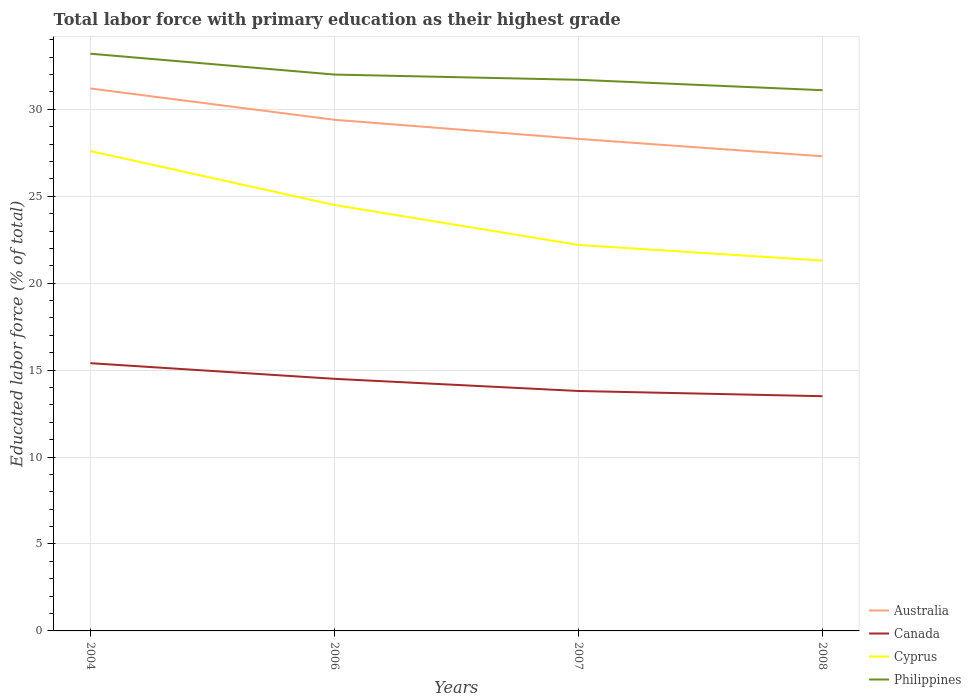How many different coloured lines are there?
Provide a succinct answer. 4. Does the line corresponding to Australia intersect with the line corresponding to Philippines?
Offer a terse response. No. Across all years, what is the maximum percentage of total labor force with primary education in Cyprus?
Offer a terse response. 21.3. What is the total percentage of total labor force with primary education in Australia in the graph?
Give a very brief answer. 3.9. What is the difference between the highest and the second highest percentage of total labor force with primary education in Canada?
Keep it short and to the point. 1.9. Is the percentage of total labor force with primary education in Philippines strictly greater than the percentage of total labor force with primary education in Canada over the years?
Offer a very short reply. No. How many lines are there?
Keep it short and to the point. 4. How many years are there in the graph?
Give a very brief answer. 4. What is the difference between two consecutive major ticks on the Y-axis?
Ensure brevity in your answer.  5. Are the values on the major ticks of Y-axis written in scientific E-notation?
Offer a very short reply. No. How are the legend labels stacked?
Your answer should be very brief. Vertical. What is the title of the graph?
Offer a very short reply. Total labor force with primary education as their highest grade. What is the label or title of the Y-axis?
Offer a very short reply. Educated labor force (% of total). What is the Educated labor force (% of total) of Australia in 2004?
Your response must be concise. 31.2. What is the Educated labor force (% of total) in Canada in 2004?
Offer a very short reply. 15.4. What is the Educated labor force (% of total) in Cyprus in 2004?
Provide a succinct answer. 27.6. What is the Educated labor force (% of total) in Philippines in 2004?
Your answer should be compact. 33.2. What is the Educated labor force (% of total) in Australia in 2006?
Give a very brief answer. 29.4. What is the Educated labor force (% of total) in Cyprus in 2006?
Keep it short and to the point. 24.5. What is the Educated labor force (% of total) of Australia in 2007?
Your response must be concise. 28.3. What is the Educated labor force (% of total) of Canada in 2007?
Ensure brevity in your answer.  13.8. What is the Educated labor force (% of total) in Cyprus in 2007?
Provide a succinct answer. 22.2. What is the Educated labor force (% of total) of Philippines in 2007?
Offer a very short reply. 31.7. What is the Educated labor force (% of total) of Australia in 2008?
Keep it short and to the point. 27.3. What is the Educated labor force (% of total) of Canada in 2008?
Provide a succinct answer. 13.5. What is the Educated labor force (% of total) of Cyprus in 2008?
Keep it short and to the point. 21.3. What is the Educated labor force (% of total) of Philippines in 2008?
Offer a terse response. 31.1. Across all years, what is the maximum Educated labor force (% of total) of Australia?
Offer a very short reply. 31.2. Across all years, what is the maximum Educated labor force (% of total) of Canada?
Ensure brevity in your answer.  15.4. Across all years, what is the maximum Educated labor force (% of total) in Cyprus?
Make the answer very short. 27.6. Across all years, what is the maximum Educated labor force (% of total) of Philippines?
Offer a very short reply. 33.2. Across all years, what is the minimum Educated labor force (% of total) in Australia?
Offer a terse response. 27.3. Across all years, what is the minimum Educated labor force (% of total) in Canada?
Ensure brevity in your answer.  13.5. Across all years, what is the minimum Educated labor force (% of total) in Cyprus?
Your answer should be very brief. 21.3. Across all years, what is the minimum Educated labor force (% of total) of Philippines?
Provide a short and direct response. 31.1. What is the total Educated labor force (% of total) of Australia in the graph?
Make the answer very short. 116.2. What is the total Educated labor force (% of total) in Canada in the graph?
Provide a short and direct response. 57.2. What is the total Educated labor force (% of total) of Cyprus in the graph?
Offer a terse response. 95.6. What is the total Educated labor force (% of total) in Philippines in the graph?
Offer a terse response. 128. What is the difference between the Educated labor force (% of total) of Australia in 2004 and that in 2006?
Your answer should be very brief. 1.8. What is the difference between the Educated labor force (% of total) in Cyprus in 2004 and that in 2006?
Ensure brevity in your answer.  3.1. What is the difference between the Educated labor force (% of total) of Canada in 2004 and that in 2007?
Provide a short and direct response. 1.6. What is the difference between the Educated labor force (% of total) of Cyprus in 2004 and that in 2007?
Your answer should be compact. 5.4. What is the difference between the Educated labor force (% of total) of Philippines in 2004 and that in 2007?
Give a very brief answer. 1.5. What is the difference between the Educated labor force (% of total) in Canada in 2004 and that in 2008?
Offer a terse response. 1.9. What is the difference between the Educated labor force (% of total) of Philippines in 2004 and that in 2008?
Ensure brevity in your answer.  2.1. What is the difference between the Educated labor force (% of total) of Australia in 2006 and that in 2007?
Your response must be concise. 1.1. What is the difference between the Educated labor force (% of total) in Cyprus in 2006 and that in 2007?
Your answer should be very brief. 2.3. What is the difference between the Educated labor force (% of total) in Australia in 2006 and that in 2008?
Ensure brevity in your answer.  2.1. What is the difference between the Educated labor force (% of total) in Cyprus in 2006 and that in 2008?
Provide a succinct answer. 3.2. What is the difference between the Educated labor force (% of total) in Australia in 2007 and that in 2008?
Provide a short and direct response. 1. What is the difference between the Educated labor force (% of total) of Canada in 2007 and that in 2008?
Give a very brief answer. 0.3. What is the difference between the Educated labor force (% of total) in Philippines in 2007 and that in 2008?
Your response must be concise. 0.6. What is the difference between the Educated labor force (% of total) in Australia in 2004 and the Educated labor force (% of total) in Cyprus in 2006?
Your answer should be compact. 6.7. What is the difference between the Educated labor force (% of total) of Australia in 2004 and the Educated labor force (% of total) of Philippines in 2006?
Give a very brief answer. -0.8. What is the difference between the Educated labor force (% of total) in Canada in 2004 and the Educated labor force (% of total) in Philippines in 2006?
Keep it short and to the point. -16.6. What is the difference between the Educated labor force (% of total) of Australia in 2004 and the Educated labor force (% of total) of Canada in 2007?
Ensure brevity in your answer.  17.4. What is the difference between the Educated labor force (% of total) in Canada in 2004 and the Educated labor force (% of total) in Philippines in 2007?
Provide a succinct answer. -16.3. What is the difference between the Educated labor force (% of total) in Australia in 2004 and the Educated labor force (% of total) in Canada in 2008?
Keep it short and to the point. 17.7. What is the difference between the Educated labor force (% of total) of Australia in 2004 and the Educated labor force (% of total) of Cyprus in 2008?
Provide a succinct answer. 9.9. What is the difference between the Educated labor force (% of total) in Canada in 2004 and the Educated labor force (% of total) in Cyprus in 2008?
Offer a very short reply. -5.9. What is the difference between the Educated labor force (% of total) in Canada in 2004 and the Educated labor force (% of total) in Philippines in 2008?
Make the answer very short. -15.7. What is the difference between the Educated labor force (% of total) in Canada in 2006 and the Educated labor force (% of total) in Philippines in 2007?
Your response must be concise. -17.2. What is the difference between the Educated labor force (% of total) of Canada in 2006 and the Educated labor force (% of total) of Cyprus in 2008?
Your response must be concise. -6.8. What is the difference between the Educated labor force (% of total) of Canada in 2006 and the Educated labor force (% of total) of Philippines in 2008?
Ensure brevity in your answer.  -16.6. What is the difference between the Educated labor force (% of total) of Cyprus in 2006 and the Educated labor force (% of total) of Philippines in 2008?
Offer a terse response. -6.6. What is the difference between the Educated labor force (% of total) of Australia in 2007 and the Educated labor force (% of total) of Philippines in 2008?
Give a very brief answer. -2.8. What is the difference between the Educated labor force (% of total) of Canada in 2007 and the Educated labor force (% of total) of Philippines in 2008?
Your response must be concise. -17.3. What is the average Educated labor force (% of total) in Australia per year?
Your response must be concise. 29.05. What is the average Educated labor force (% of total) in Canada per year?
Offer a very short reply. 14.3. What is the average Educated labor force (% of total) in Cyprus per year?
Offer a terse response. 23.9. What is the average Educated labor force (% of total) in Philippines per year?
Provide a succinct answer. 32. In the year 2004, what is the difference between the Educated labor force (% of total) in Australia and Educated labor force (% of total) in Canada?
Provide a short and direct response. 15.8. In the year 2004, what is the difference between the Educated labor force (% of total) of Australia and Educated labor force (% of total) of Cyprus?
Provide a succinct answer. 3.6. In the year 2004, what is the difference between the Educated labor force (% of total) of Canada and Educated labor force (% of total) of Philippines?
Ensure brevity in your answer.  -17.8. In the year 2006, what is the difference between the Educated labor force (% of total) of Australia and Educated labor force (% of total) of Philippines?
Your answer should be compact. -2.6. In the year 2006, what is the difference between the Educated labor force (% of total) of Canada and Educated labor force (% of total) of Philippines?
Keep it short and to the point. -17.5. In the year 2007, what is the difference between the Educated labor force (% of total) in Australia and Educated labor force (% of total) in Canada?
Offer a very short reply. 14.5. In the year 2007, what is the difference between the Educated labor force (% of total) of Australia and Educated labor force (% of total) of Cyprus?
Provide a short and direct response. 6.1. In the year 2007, what is the difference between the Educated labor force (% of total) in Australia and Educated labor force (% of total) in Philippines?
Give a very brief answer. -3.4. In the year 2007, what is the difference between the Educated labor force (% of total) in Canada and Educated labor force (% of total) in Philippines?
Provide a short and direct response. -17.9. In the year 2007, what is the difference between the Educated labor force (% of total) of Cyprus and Educated labor force (% of total) of Philippines?
Provide a short and direct response. -9.5. In the year 2008, what is the difference between the Educated labor force (% of total) of Australia and Educated labor force (% of total) of Philippines?
Give a very brief answer. -3.8. In the year 2008, what is the difference between the Educated labor force (% of total) of Canada and Educated labor force (% of total) of Cyprus?
Provide a short and direct response. -7.8. In the year 2008, what is the difference between the Educated labor force (% of total) of Canada and Educated labor force (% of total) of Philippines?
Ensure brevity in your answer.  -17.6. In the year 2008, what is the difference between the Educated labor force (% of total) in Cyprus and Educated labor force (% of total) in Philippines?
Your answer should be very brief. -9.8. What is the ratio of the Educated labor force (% of total) in Australia in 2004 to that in 2006?
Your answer should be compact. 1.06. What is the ratio of the Educated labor force (% of total) of Canada in 2004 to that in 2006?
Keep it short and to the point. 1.06. What is the ratio of the Educated labor force (% of total) in Cyprus in 2004 to that in 2006?
Give a very brief answer. 1.13. What is the ratio of the Educated labor force (% of total) of Philippines in 2004 to that in 2006?
Give a very brief answer. 1.04. What is the ratio of the Educated labor force (% of total) in Australia in 2004 to that in 2007?
Make the answer very short. 1.1. What is the ratio of the Educated labor force (% of total) in Canada in 2004 to that in 2007?
Make the answer very short. 1.12. What is the ratio of the Educated labor force (% of total) of Cyprus in 2004 to that in 2007?
Your response must be concise. 1.24. What is the ratio of the Educated labor force (% of total) in Philippines in 2004 to that in 2007?
Provide a succinct answer. 1.05. What is the ratio of the Educated labor force (% of total) in Canada in 2004 to that in 2008?
Your answer should be very brief. 1.14. What is the ratio of the Educated labor force (% of total) in Cyprus in 2004 to that in 2008?
Your answer should be compact. 1.3. What is the ratio of the Educated labor force (% of total) of Philippines in 2004 to that in 2008?
Offer a terse response. 1.07. What is the ratio of the Educated labor force (% of total) in Australia in 2006 to that in 2007?
Your response must be concise. 1.04. What is the ratio of the Educated labor force (% of total) in Canada in 2006 to that in 2007?
Offer a very short reply. 1.05. What is the ratio of the Educated labor force (% of total) of Cyprus in 2006 to that in 2007?
Keep it short and to the point. 1.1. What is the ratio of the Educated labor force (% of total) of Philippines in 2006 to that in 2007?
Ensure brevity in your answer.  1.01. What is the ratio of the Educated labor force (% of total) in Canada in 2006 to that in 2008?
Provide a short and direct response. 1.07. What is the ratio of the Educated labor force (% of total) in Cyprus in 2006 to that in 2008?
Offer a terse response. 1.15. What is the ratio of the Educated labor force (% of total) of Philippines in 2006 to that in 2008?
Make the answer very short. 1.03. What is the ratio of the Educated labor force (% of total) in Australia in 2007 to that in 2008?
Offer a terse response. 1.04. What is the ratio of the Educated labor force (% of total) of Canada in 2007 to that in 2008?
Provide a succinct answer. 1.02. What is the ratio of the Educated labor force (% of total) in Cyprus in 2007 to that in 2008?
Your answer should be compact. 1.04. What is the ratio of the Educated labor force (% of total) in Philippines in 2007 to that in 2008?
Keep it short and to the point. 1.02. What is the difference between the highest and the second highest Educated labor force (% of total) in Australia?
Make the answer very short. 1.8. What is the difference between the highest and the second highest Educated labor force (% of total) in Canada?
Make the answer very short. 0.9. What is the difference between the highest and the second highest Educated labor force (% of total) of Philippines?
Make the answer very short. 1.2. What is the difference between the highest and the lowest Educated labor force (% of total) of Canada?
Offer a terse response. 1.9. What is the difference between the highest and the lowest Educated labor force (% of total) in Cyprus?
Provide a short and direct response. 6.3. 